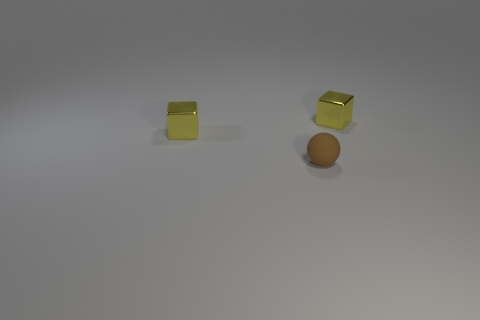Can you suggest what the yellow cubes and the sphere might symbolize or represent? Symbolism is subjective, but the yellow cubes could represent structure or artificial constructs, while the brown sphere might symbolize something natural or organic. Their interaction or positioning could reflect balance, contrast, or coexistence. 